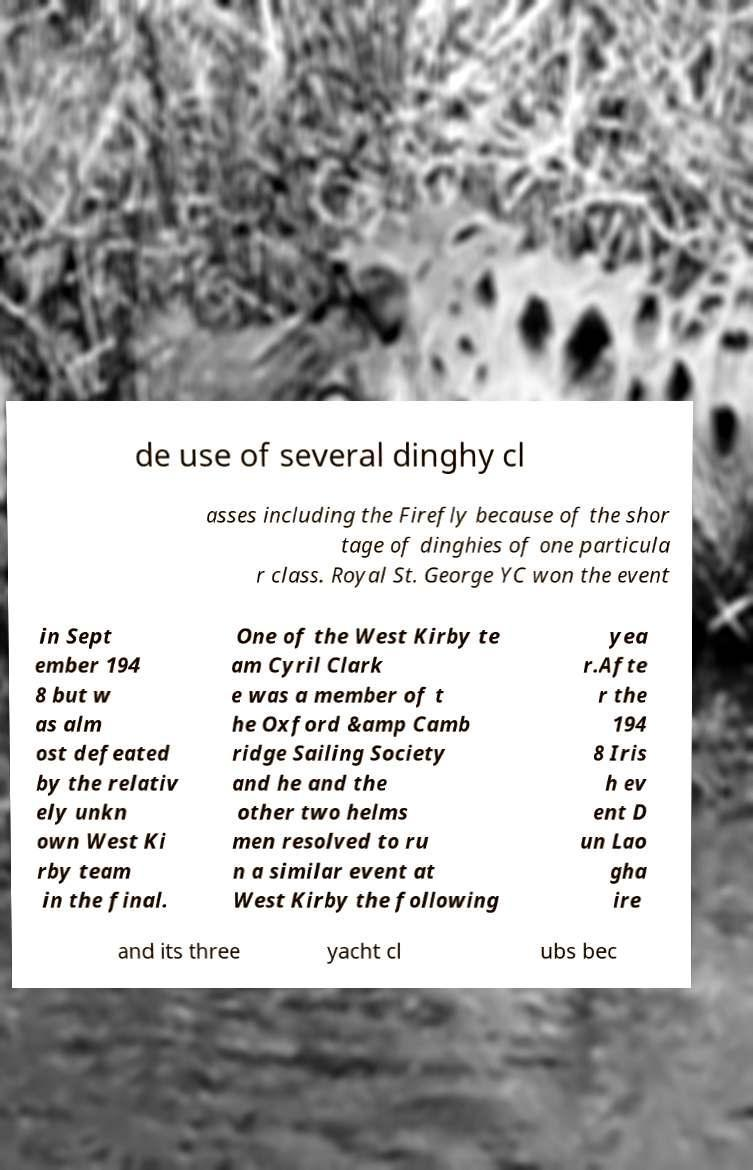For documentation purposes, I need the text within this image transcribed. Could you provide that? de use of several dinghy cl asses including the Firefly because of the shor tage of dinghies of one particula r class. Royal St. George YC won the event in Sept ember 194 8 but w as alm ost defeated by the relativ ely unkn own West Ki rby team in the final. One of the West Kirby te am Cyril Clark e was a member of t he Oxford &amp Camb ridge Sailing Society and he and the other two helms men resolved to ru n a similar event at West Kirby the following yea r.Afte r the 194 8 Iris h ev ent D un Lao gha ire and its three yacht cl ubs bec 